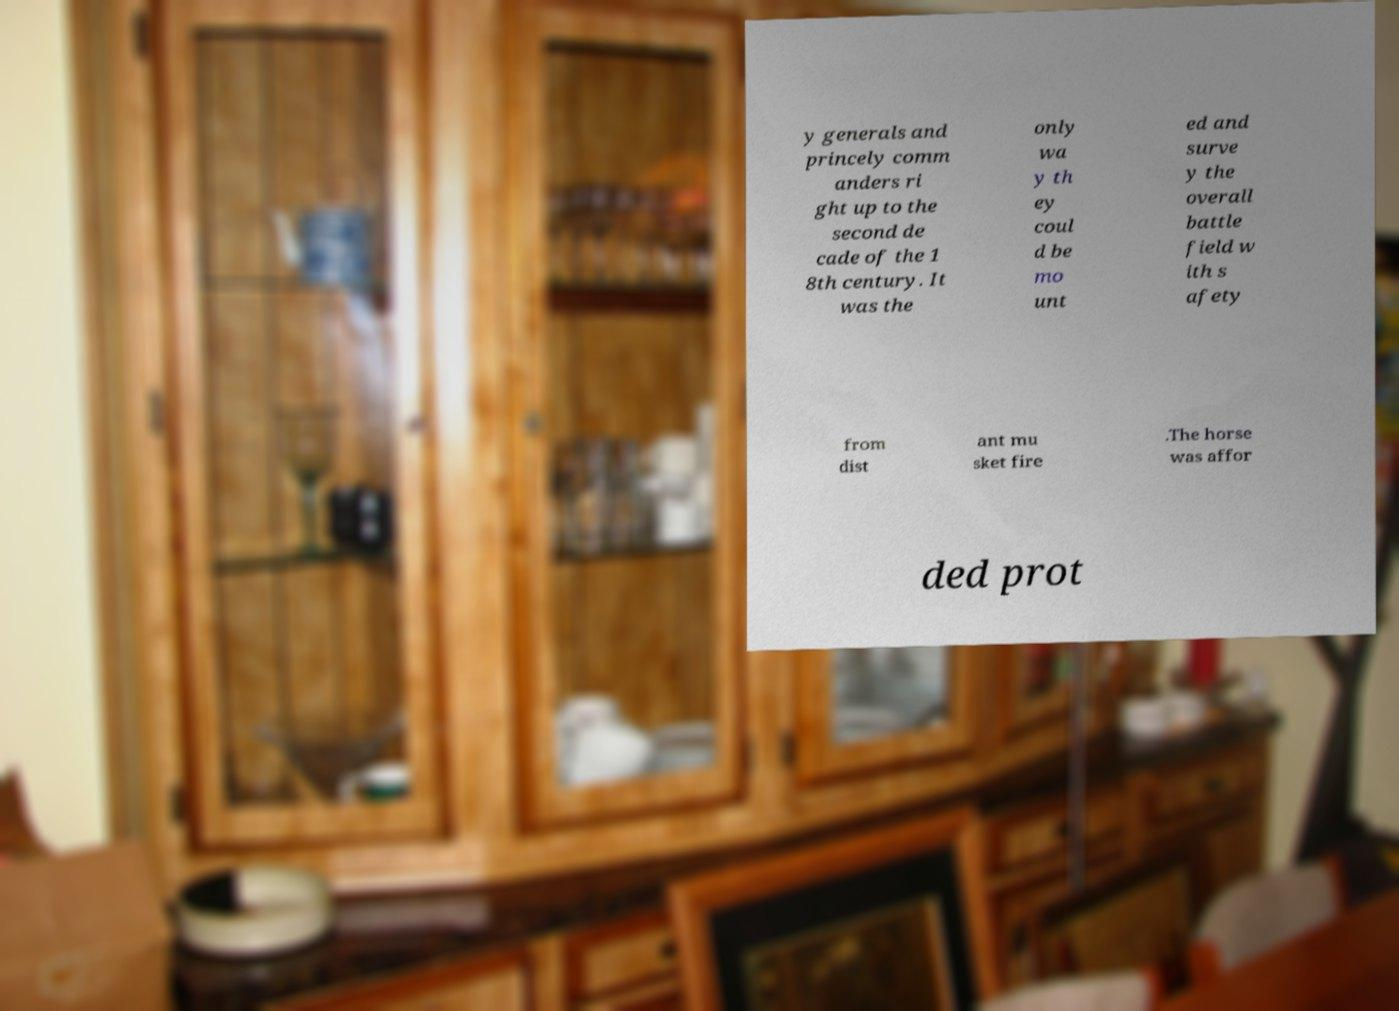Please read and relay the text visible in this image. What does it say? y generals and princely comm anders ri ght up to the second de cade of the 1 8th century. It was the only wa y th ey coul d be mo unt ed and surve y the overall battle field w ith s afety from dist ant mu sket fire .The horse was affor ded prot 